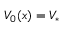Convert formula to latex. <formula><loc_0><loc_0><loc_500><loc_500>V _ { 0 } ( x ) = V _ { * }</formula> 